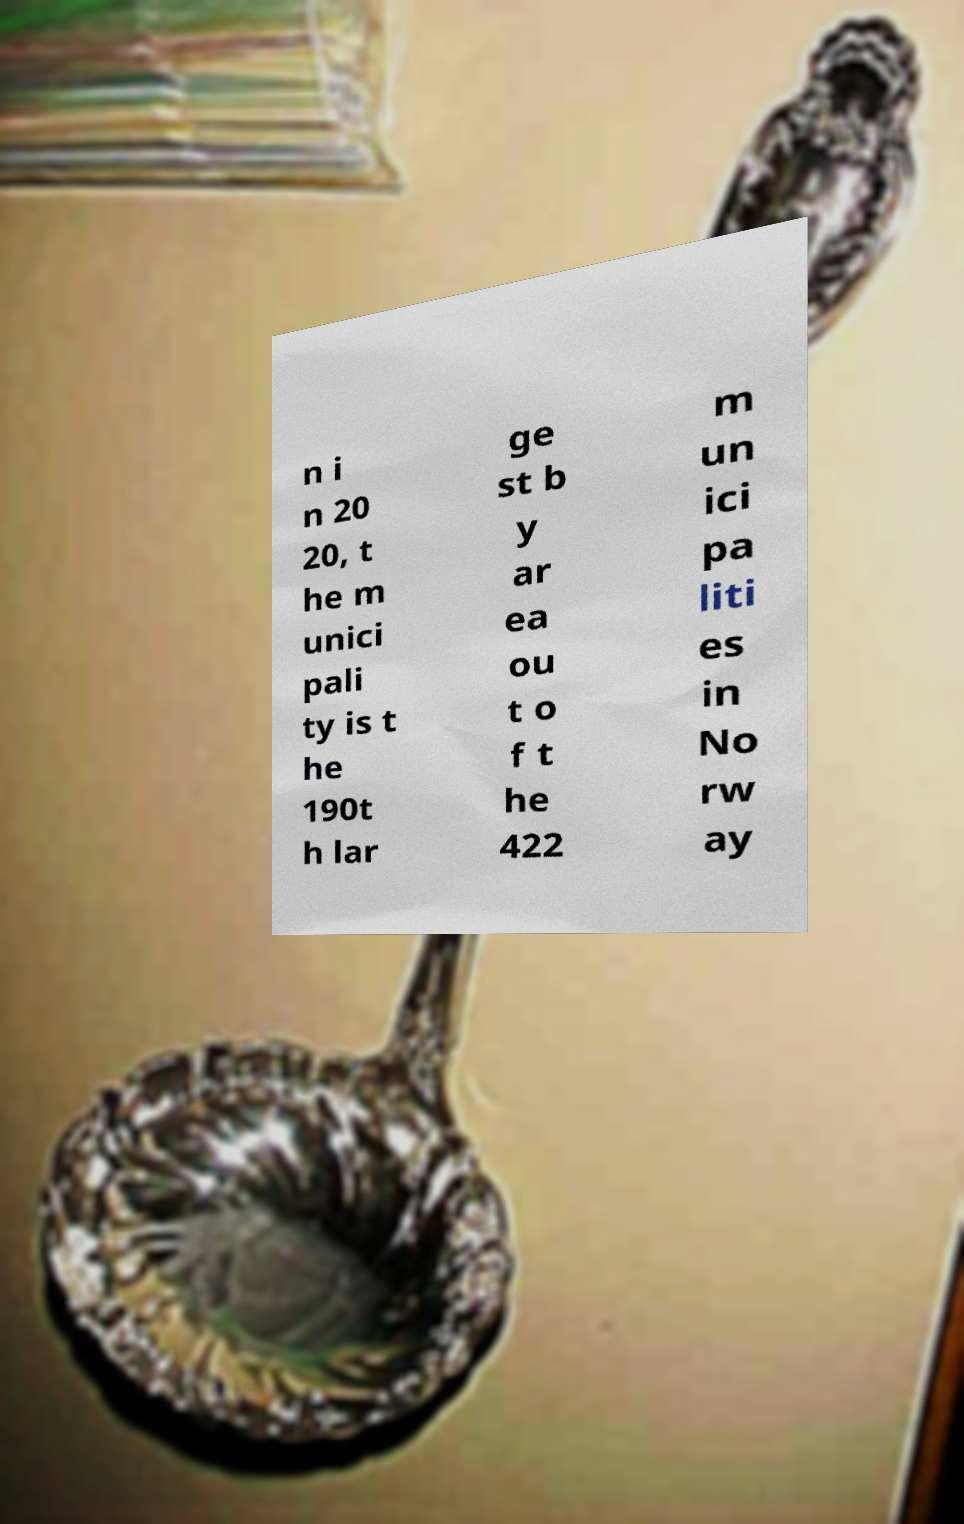There's text embedded in this image that I need extracted. Can you transcribe it verbatim? n i n 20 20, t he m unici pali ty is t he 190t h lar ge st b y ar ea ou t o f t he 422 m un ici pa liti es in No rw ay 